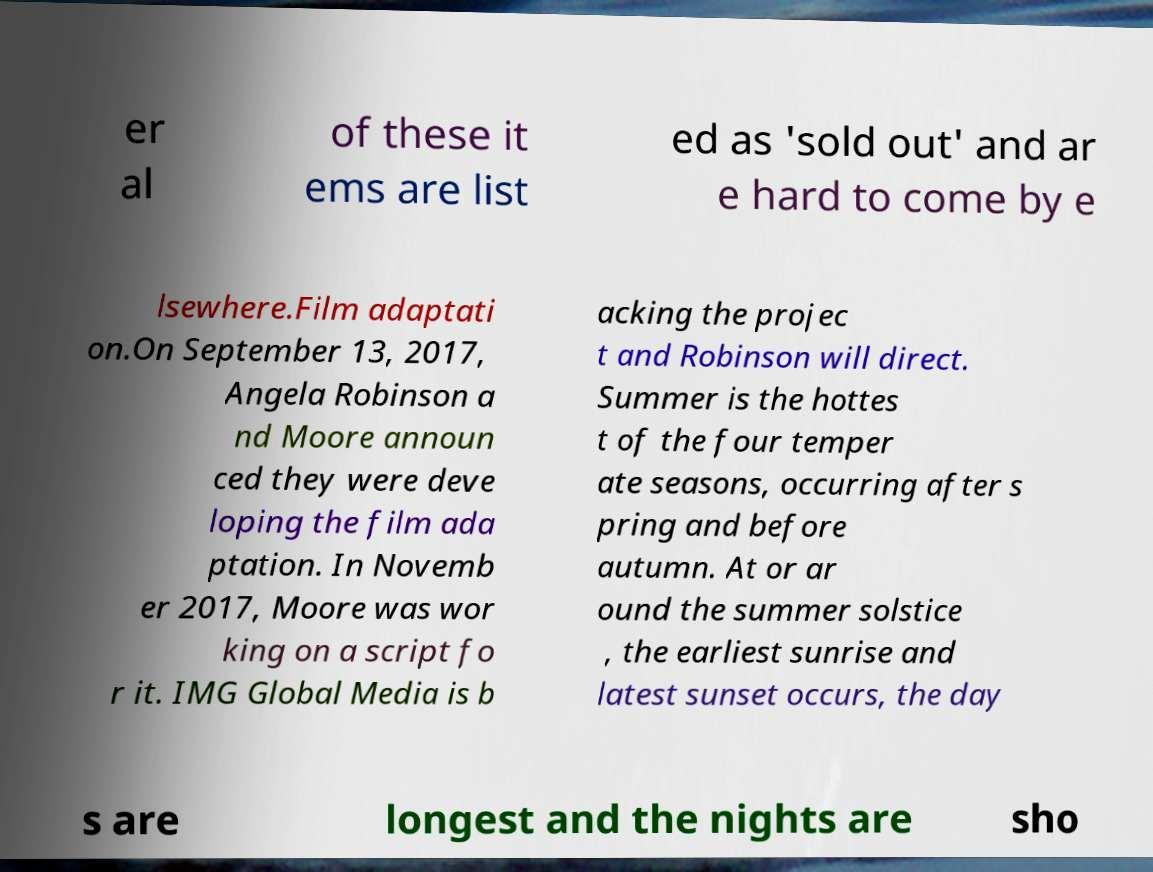For documentation purposes, I need the text within this image transcribed. Could you provide that? er al of these it ems are list ed as 'sold out' and ar e hard to come by e lsewhere.Film adaptati on.On September 13, 2017, Angela Robinson a nd Moore announ ced they were deve loping the film ada ptation. In Novemb er 2017, Moore was wor king on a script fo r it. IMG Global Media is b acking the projec t and Robinson will direct. Summer is the hottes t of the four temper ate seasons, occurring after s pring and before autumn. At or ar ound the summer solstice , the earliest sunrise and latest sunset occurs, the day s are longest and the nights are sho 